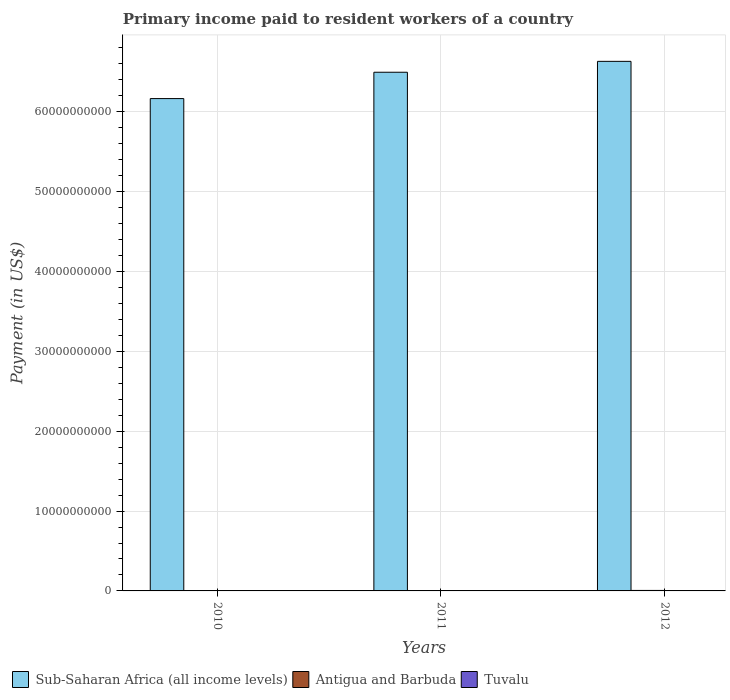Are the number of bars on each tick of the X-axis equal?
Offer a very short reply. Yes. How many bars are there on the 3rd tick from the left?
Offer a terse response. 3. How many bars are there on the 1st tick from the right?
Your answer should be very brief. 3. What is the amount paid to workers in Sub-Saharan Africa (all income levels) in 2010?
Your answer should be very brief. 6.16e+1. Across all years, what is the maximum amount paid to workers in Antigua and Barbuda?
Your answer should be compact. 6.16e+07. Across all years, what is the minimum amount paid to workers in Sub-Saharan Africa (all income levels)?
Offer a very short reply. 6.16e+1. In which year was the amount paid to workers in Tuvalu minimum?
Your response must be concise. 2011. What is the total amount paid to workers in Tuvalu in the graph?
Give a very brief answer. 9.42e+06. What is the difference between the amount paid to workers in Antigua and Barbuda in 2011 and that in 2012?
Make the answer very short. -1.19e+07. What is the difference between the amount paid to workers in Tuvalu in 2011 and the amount paid to workers in Sub-Saharan Africa (all income levels) in 2010?
Give a very brief answer. -6.16e+1. What is the average amount paid to workers in Tuvalu per year?
Provide a succinct answer. 3.14e+06. In the year 2011, what is the difference between the amount paid to workers in Antigua and Barbuda and amount paid to workers in Tuvalu?
Provide a short and direct response. 4.73e+07. What is the ratio of the amount paid to workers in Antigua and Barbuda in 2010 to that in 2011?
Your response must be concise. 0.86. Is the difference between the amount paid to workers in Antigua and Barbuda in 2010 and 2012 greater than the difference between the amount paid to workers in Tuvalu in 2010 and 2012?
Offer a very short reply. No. What is the difference between the highest and the second highest amount paid to workers in Antigua and Barbuda?
Make the answer very short. 1.19e+07. What is the difference between the highest and the lowest amount paid to workers in Tuvalu?
Ensure brevity in your answer.  2.31e+06. In how many years, is the amount paid to workers in Antigua and Barbuda greater than the average amount paid to workers in Antigua and Barbuda taken over all years?
Give a very brief answer. 1. What does the 3rd bar from the left in 2010 represents?
Your answer should be compact. Tuvalu. What does the 2nd bar from the right in 2010 represents?
Provide a short and direct response. Antigua and Barbuda. Is it the case that in every year, the sum of the amount paid to workers in Antigua and Barbuda and amount paid to workers in Sub-Saharan Africa (all income levels) is greater than the amount paid to workers in Tuvalu?
Your answer should be very brief. Yes. How many bars are there?
Provide a short and direct response. 9. Are all the bars in the graph horizontal?
Your answer should be very brief. No. What is the difference between two consecutive major ticks on the Y-axis?
Your answer should be compact. 1.00e+1. Does the graph contain any zero values?
Offer a very short reply. No. How are the legend labels stacked?
Provide a succinct answer. Horizontal. What is the title of the graph?
Ensure brevity in your answer.  Primary income paid to resident workers of a country. What is the label or title of the X-axis?
Make the answer very short. Years. What is the label or title of the Y-axis?
Your answer should be very brief. Payment (in US$). What is the Payment (in US$) of Sub-Saharan Africa (all income levels) in 2010?
Ensure brevity in your answer.  6.16e+1. What is the Payment (in US$) in Antigua and Barbuda in 2010?
Make the answer very short. 4.26e+07. What is the Payment (in US$) in Tuvalu in 2010?
Your answer should be compact. 2.42e+06. What is the Payment (in US$) in Sub-Saharan Africa (all income levels) in 2011?
Provide a succinct answer. 6.49e+1. What is the Payment (in US$) in Antigua and Barbuda in 2011?
Keep it short and to the point. 4.97e+07. What is the Payment (in US$) of Tuvalu in 2011?
Offer a terse response. 2.35e+06. What is the Payment (in US$) in Sub-Saharan Africa (all income levels) in 2012?
Provide a succinct answer. 6.63e+1. What is the Payment (in US$) of Antigua and Barbuda in 2012?
Offer a very short reply. 6.16e+07. What is the Payment (in US$) in Tuvalu in 2012?
Offer a terse response. 4.65e+06. Across all years, what is the maximum Payment (in US$) in Sub-Saharan Africa (all income levels)?
Give a very brief answer. 6.63e+1. Across all years, what is the maximum Payment (in US$) of Antigua and Barbuda?
Your response must be concise. 6.16e+07. Across all years, what is the maximum Payment (in US$) in Tuvalu?
Your answer should be very brief. 4.65e+06. Across all years, what is the minimum Payment (in US$) in Sub-Saharan Africa (all income levels)?
Your response must be concise. 6.16e+1. Across all years, what is the minimum Payment (in US$) in Antigua and Barbuda?
Provide a succinct answer. 4.26e+07. Across all years, what is the minimum Payment (in US$) of Tuvalu?
Provide a succinct answer. 2.35e+06. What is the total Payment (in US$) in Sub-Saharan Africa (all income levels) in the graph?
Your answer should be very brief. 1.93e+11. What is the total Payment (in US$) of Antigua and Barbuda in the graph?
Make the answer very short. 1.54e+08. What is the total Payment (in US$) of Tuvalu in the graph?
Offer a very short reply. 9.42e+06. What is the difference between the Payment (in US$) in Sub-Saharan Africa (all income levels) in 2010 and that in 2011?
Make the answer very short. -3.30e+09. What is the difference between the Payment (in US$) of Antigua and Barbuda in 2010 and that in 2011?
Your answer should be very brief. -7.07e+06. What is the difference between the Payment (in US$) in Tuvalu in 2010 and that in 2011?
Provide a succinct answer. 7.36e+04. What is the difference between the Payment (in US$) in Sub-Saharan Africa (all income levels) in 2010 and that in 2012?
Provide a short and direct response. -4.66e+09. What is the difference between the Payment (in US$) in Antigua and Barbuda in 2010 and that in 2012?
Your response must be concise. -1.90e+07. What is the difference between the Payment (in US$) in Tuvalu in 2010 and that in 2012?
Ensure brevity in your answer.  -2.23e+06. What is the difference between the Payment (in US$) in Sub-Saharan Africa (all income levels) in 2011 and that in 2012?
Provide a succinct answer. -1.36e+09. What is the difference between the Payment (in US$) of Antigua and Barbuda in 2011 and that in 2012?
Your answer should be very brief. -1.19e+07. What is the difference between the Payment (in US$) of Tuvalu in 2011 and that in 2012?
Your answer should be very brief. -2.31e+06. What is the difference between the Payment (in US$) of Sub-Saharan Africa (all income levels) in 2010 and the Payment (in US$) of Antigua and Barbuda in 2011?
Keep it short and to the point. 6.16e+1. What is the difference between the Payment (in US$) in Sub-Saharan Africa (all income levels) in 2010 and the Payment (in US$) in Tuvalu in 2011?
Your answer should be very brief. 6.16e+1. What is the difference between the Payment (in US$) in Antigua and Barbuda in 2010 and the Payment (in US$) in Tuvalu in 2011?
Ensure brevity in your answer.  4.03e+07. What is the difference between the Payment (in US$) of Sub-Saharan Africa (all income levels) in 2010 and the Payment (in US$) of Antigua and Barbuda in 2012?
Your response must be concise. 6.16e+1. What is the difference between the Payment (in US$) in Sub-Saharan Africa (all income levels) in 2010 and the Payment (in US$) in Tuvalu in 2012?
Your answer should be compact. 6.16e+1. What is the difference between the Payment (in US$) in Antigua and Barbuda in 2010 and the Payment (in US$) in Tuvalu in 2012?
Offer a terse response. 3.80e+07. What is the difference between the Payment (in US$) of Sub-Saharan Africa (all income levels) in 2011 and the Payment (in US$) of Antigua and Barbuda in 2012?
Offer a terse response. 6.49e+1. What is the difference between the Payment (in US$) in Sub-Saharan Africa (all income levels) in 2011 and the Payment (in US$) in Tuvalu in 2012?
Give a very brief answer. 6.49e+1. What is the difference between the Payment (in US$) in Antigua and Barbuda in 2011 and the Payment (in US$) in Tuvalu in 2012?
Your answer should be very brief. 4.50e+07. What is the average Payment (in US$) in Sub-Saharan Africa (all income levels) per year?
Your answer should be compact. 6.43e+1. What is the average Payment (in US$) in Antigua and Barbuda per year?
Your answer should be compact. 5.13e+07. What is the average Payment (in US$) of Tuvalu per year?
Keep it short and to the point. 3.14e+06. In the year 2010, what is the difference between the Payment (in US$) in Sub-Saharan Africa (all income levels) and Payment (in US$) in Antigua and Barbuda?
Make the answer very short. 6.16e+1. In the year 2010, what is the difference between the Payment (in US$) in Sub-Saharan Africa (all income levels) and Payment (in US$) in Tuvalu?
Give a very brief answer. 6.16e+1. In the year 2010, what is the difference between the Payment (in US$) in Antigua and Barbuda and Payment (in US$) in Tuvalu?
Provide a short and direct response. 4.02e+07. In the year 2011, what is the difference between the Payment (in US$) in Sub-Saharan Africa (all income levels) and Payment (in US$) in Antigua and Barbuda?
Provide a short and direct response. 6.49e+1. In the year 2011, what is the difference between the Payment (in US$) in Sub-Saharan Africa (all income levels) and Payment (in US$) in Tuvalu?
Offer a very short reply. 6.49e+1. In the year 2011, what is the difference between the Payment (in US$) of Antigua and Barbuda and Payment (in US$) of Tuvalu?
Give a very brief answer. 4.73e+07. In the year 2012, what is the difference between the Payment (in US$) of Sub-Saharan Africa (all income levels) and Payment (in US$) of Antigua and Barbuda?
Your answer should be very brief. 6.62e+1. In the year 2012, what is the difference between the Payment (in US$) in Sub-Saharan Africa (all income levels) and Payment (in US$) in Tuvalu?
Give a very brief answer. 6.63e+1. In the year 2012, what is the difference between the Payment (in US$) of Antigua and Barbuda and Payment (in US$) of Tuvalu?
Keep it short and to the point. 5.69e+07. What is the ratio of the Payment (in US$) in Sub-Saharan Africa (all income levels) in 2010 to that in 2011?
Your answer should be very brief. 0.95. What is the ratio of the Payment (in US$) of Antigua and Barbuda in 2010 to that in 2011?
Your answer should be very brief. 0.86. What is the ratio of the Payment (in US$) in Tuvalu in 2010 to that in 2011?
Your answer should be very brief. 1.03. What is the ratio of the Payment (in US$) in Sub-Saharan Africa (all income levels) in 2010 to that in 2012?
Give a very brief answer. 0.93. What is the ratio of the Payment (in US$) of Antigua and Barbuda in 2010 to that in 2012?
Make the answer very short. 0.69. What is the ratio of the Payment (in US$) in Tuvalu in 2010 to that in 2012?
Your response must be concise. 0.52. What is the ratio of the Payment (in US$) in Sub-Saharan Africa (all income levels) in 2011 to that in 2012?
Provide a short and direct response. 0.98. What is the ratio of the Payment (in US$) of Antigua and Barbuda in 2011 to that in 2012?
Provide a succinct answer. 0.81. What is the ratio of the Payment (in US$) in Tuvalu in 2011 to that in 2012?
Give a very brief answer. 0.5. What is the difference between the highest and the second highest Payment (in US$) of Sub-Saharan Africa (all income levels)?
Offer a terse response. 1.36e+09. What is the difference between the highest and the second highest Payment (in US$) of Antigua and Barbuda?
Make the answer very short. 1.19e+07. What is the difference between the highest and the second highest Payment (in US$) of Tuvalu?
Make the answer very short. 2.23e+06. What is the difference between the highest and the lowest Payment (in US$) of Sub-Saharan Africa (all income levels)?
Your answer should be very brief. 4.66e+09. What is the difference between the highest and the lowest Payment (in US$) in Antigua and Barbuda?
Your answer should be compact. 1.90e+07. What is the difference between the highest and the lowest Payment (in US$) in Tuvalu?
Ensure brevity in your answer.  2.31e+06. 